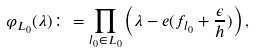<formula> <loc_0><loc_0><loc_500><loc_500>\varphi _ { L _ { 0 } } ( \lambda ) \colon = \prod _ { l _ { 0 } \in L _ { 0 } } \left ( \lambda - { e } ( f _ { l _ { 0 } } + \frac { \epsilon } { h } ) \right ) ,</formula> 